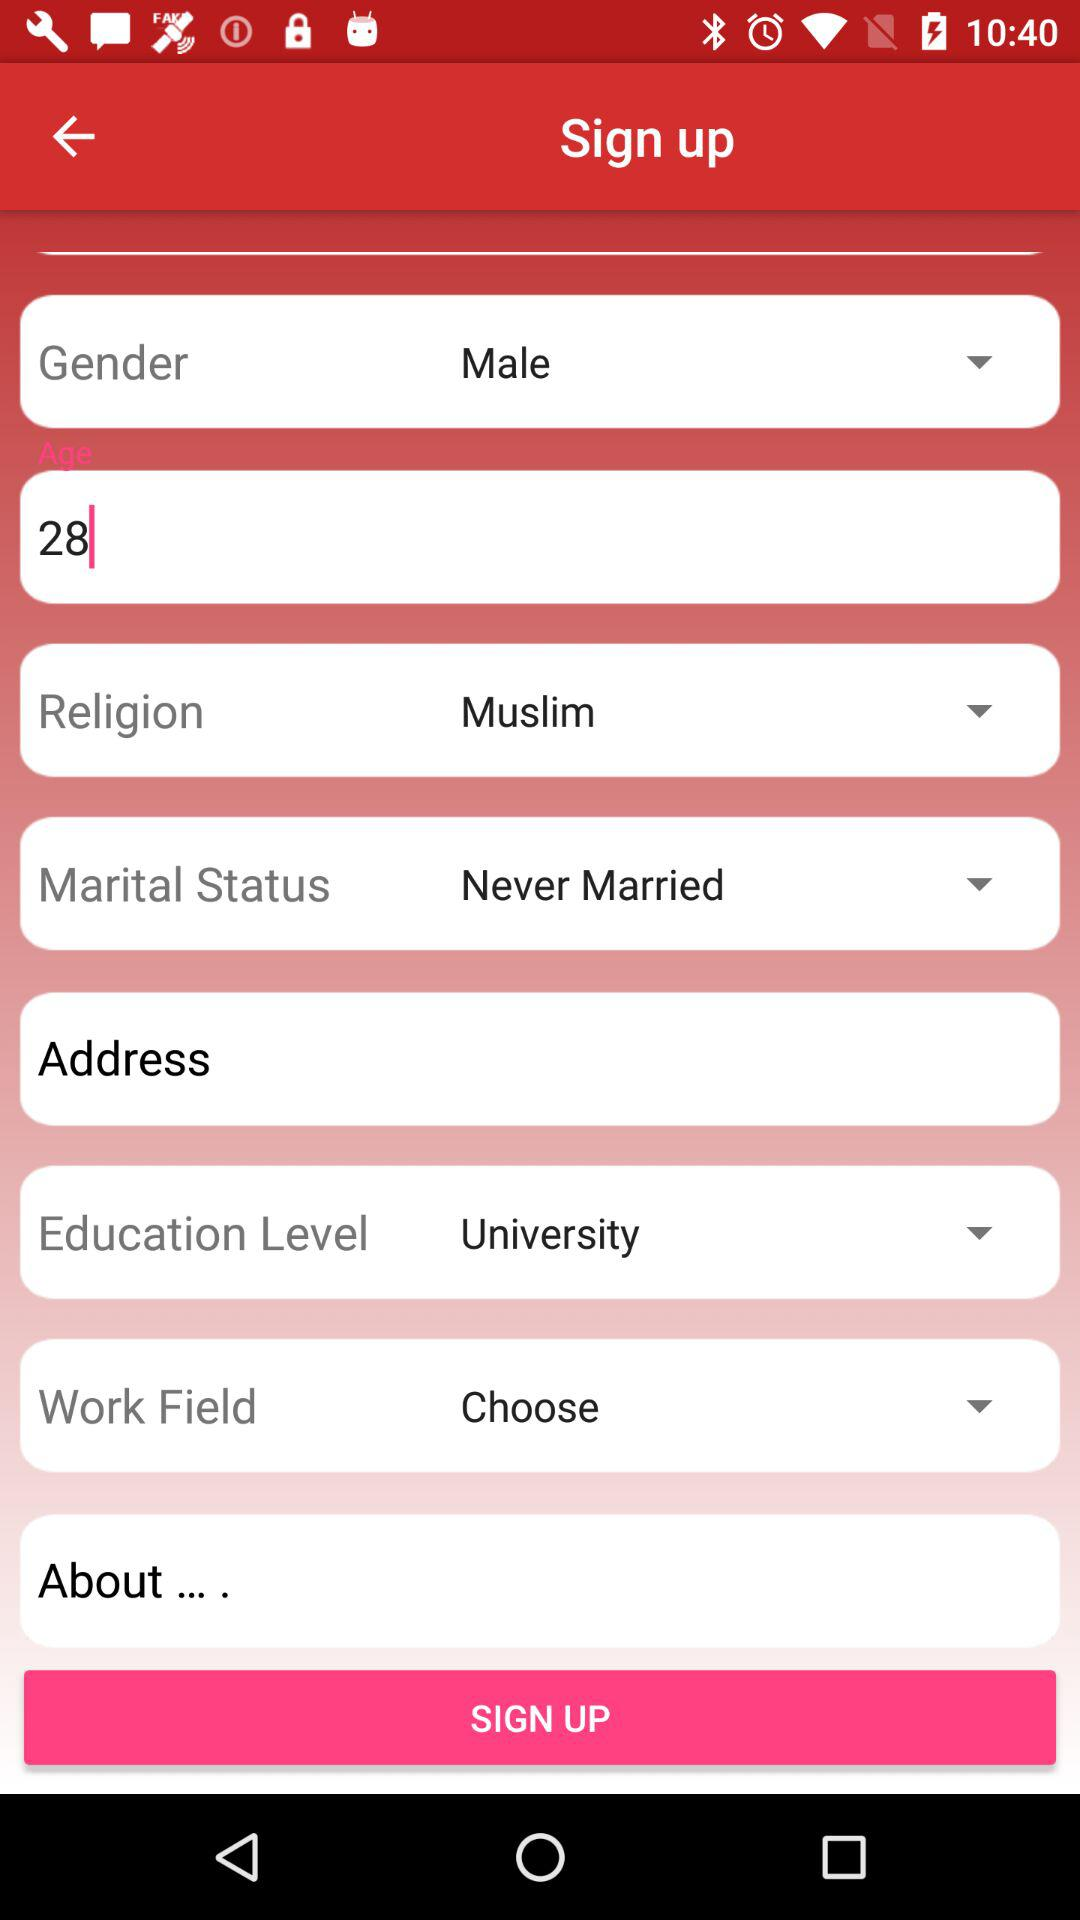What is the age of the user? The age of the user is 28 years old. 